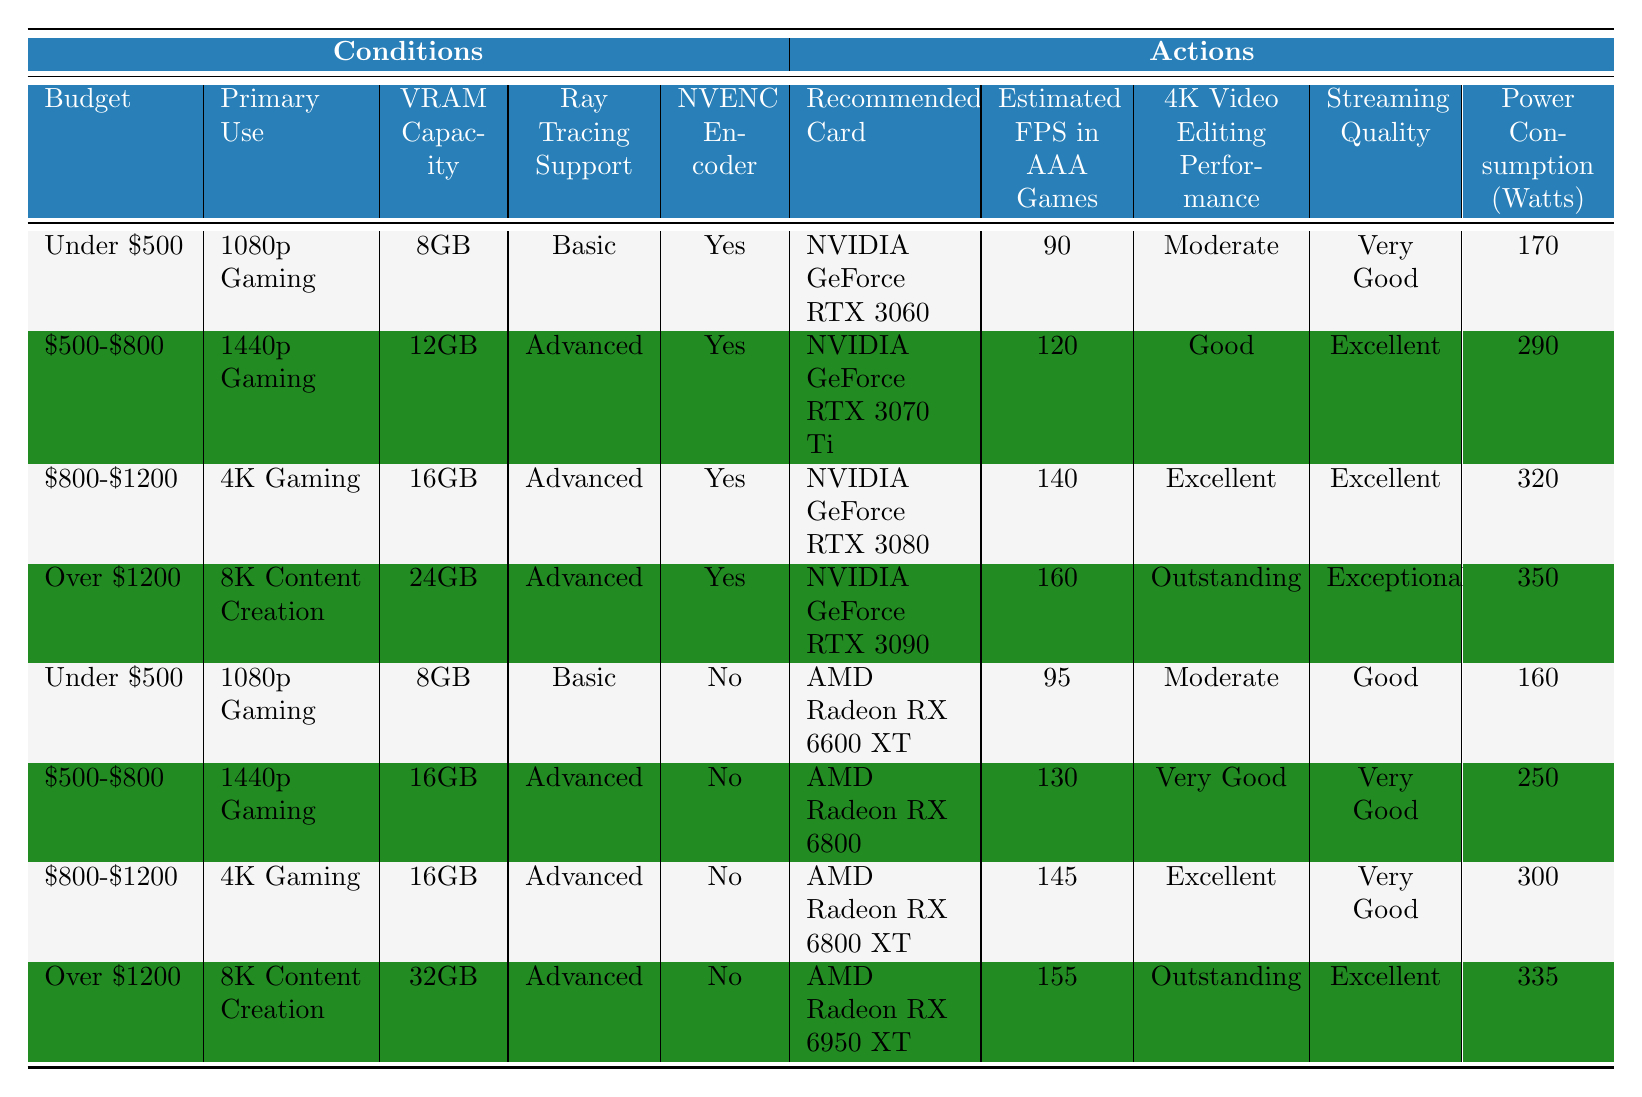What is the recommended graphics card for 4K gaming with a budget of $800-$1200? The table shows that for the budget range of $800-$1200, the recommended card for 4K gaming is the NVIDIA GeForce RTX 3080.
Answer: NVIDIA GeForce RTX 3080 Which graphics card has the highest estimated FPS in AAA games? Looking through the table, the graphics card with the highest estimated FPS in AAA games is the NVIDIA GeForce RTX 3090, which has an estimated FPS of 160.
Answer: NVIDIA GeForce RTX 3090 Is it true that all cards listed for 8K content creation support the NVENC encoder? Checking the rows where the primary use is for 8K content creation, the NVIDIA GeForce RTX 3090 and the AMD Radeon RX 6950 XT are both listed, but only the RTX 3090 supports the NVENC encoder. Thus, it is false that all cards listed support NVENC.
Answer: False What is the average power consumption (in watts) for graphics cards suited for 1440p gaming? The relevant cards for 1440p gaming are the NVIDIA GeForce RTX 3070 Ti (290 watts) and the AMD Radeon RX 6800 (250 watts). To find the average, calculate (290 + 250) / 2 = 270.
Answer: 270 Which card has better 4K video editing performance, the NVIDIA GeForce RTX 3080 or the AMD Radeon RX 6800 XT? In the table, the 4K video editing performance for the NVIDIA GeForce RTX 3080 is rated as Excellent, while the AMD Radeon RX 6800 XT is rated as Very Good. Therefore, the RTX 3080 has better performance in this category.
Answer: NVIDIA GeForce RTX 3080 What is the difference in power consumption between the AMD Radeon RX 6600 XT and the NVIDIA GeForce RTX 3060? The AMD Radeon RX 6600 XT consumes 160 watts, and the NVIDIA GeForce RTX 3060 consumes 170 watts. The difference is 170 - 160 = 10 watts.
Answer: 10 watts Are there any graphics cards under $500 that support advanced ray tracing? By examining the table, there are no cards under $500 listed that support advanced ray tracing; both cards in that category support only basic ray tracing. Hence, the answer is no.
Answer: No What is the estimated FPS in AAA games for the AMD Radeon RX 6800 XT? According to the table, the estimated FPS in AAA games for the AMD Radeon RX 6800 XT is 145.
Answer: 145 